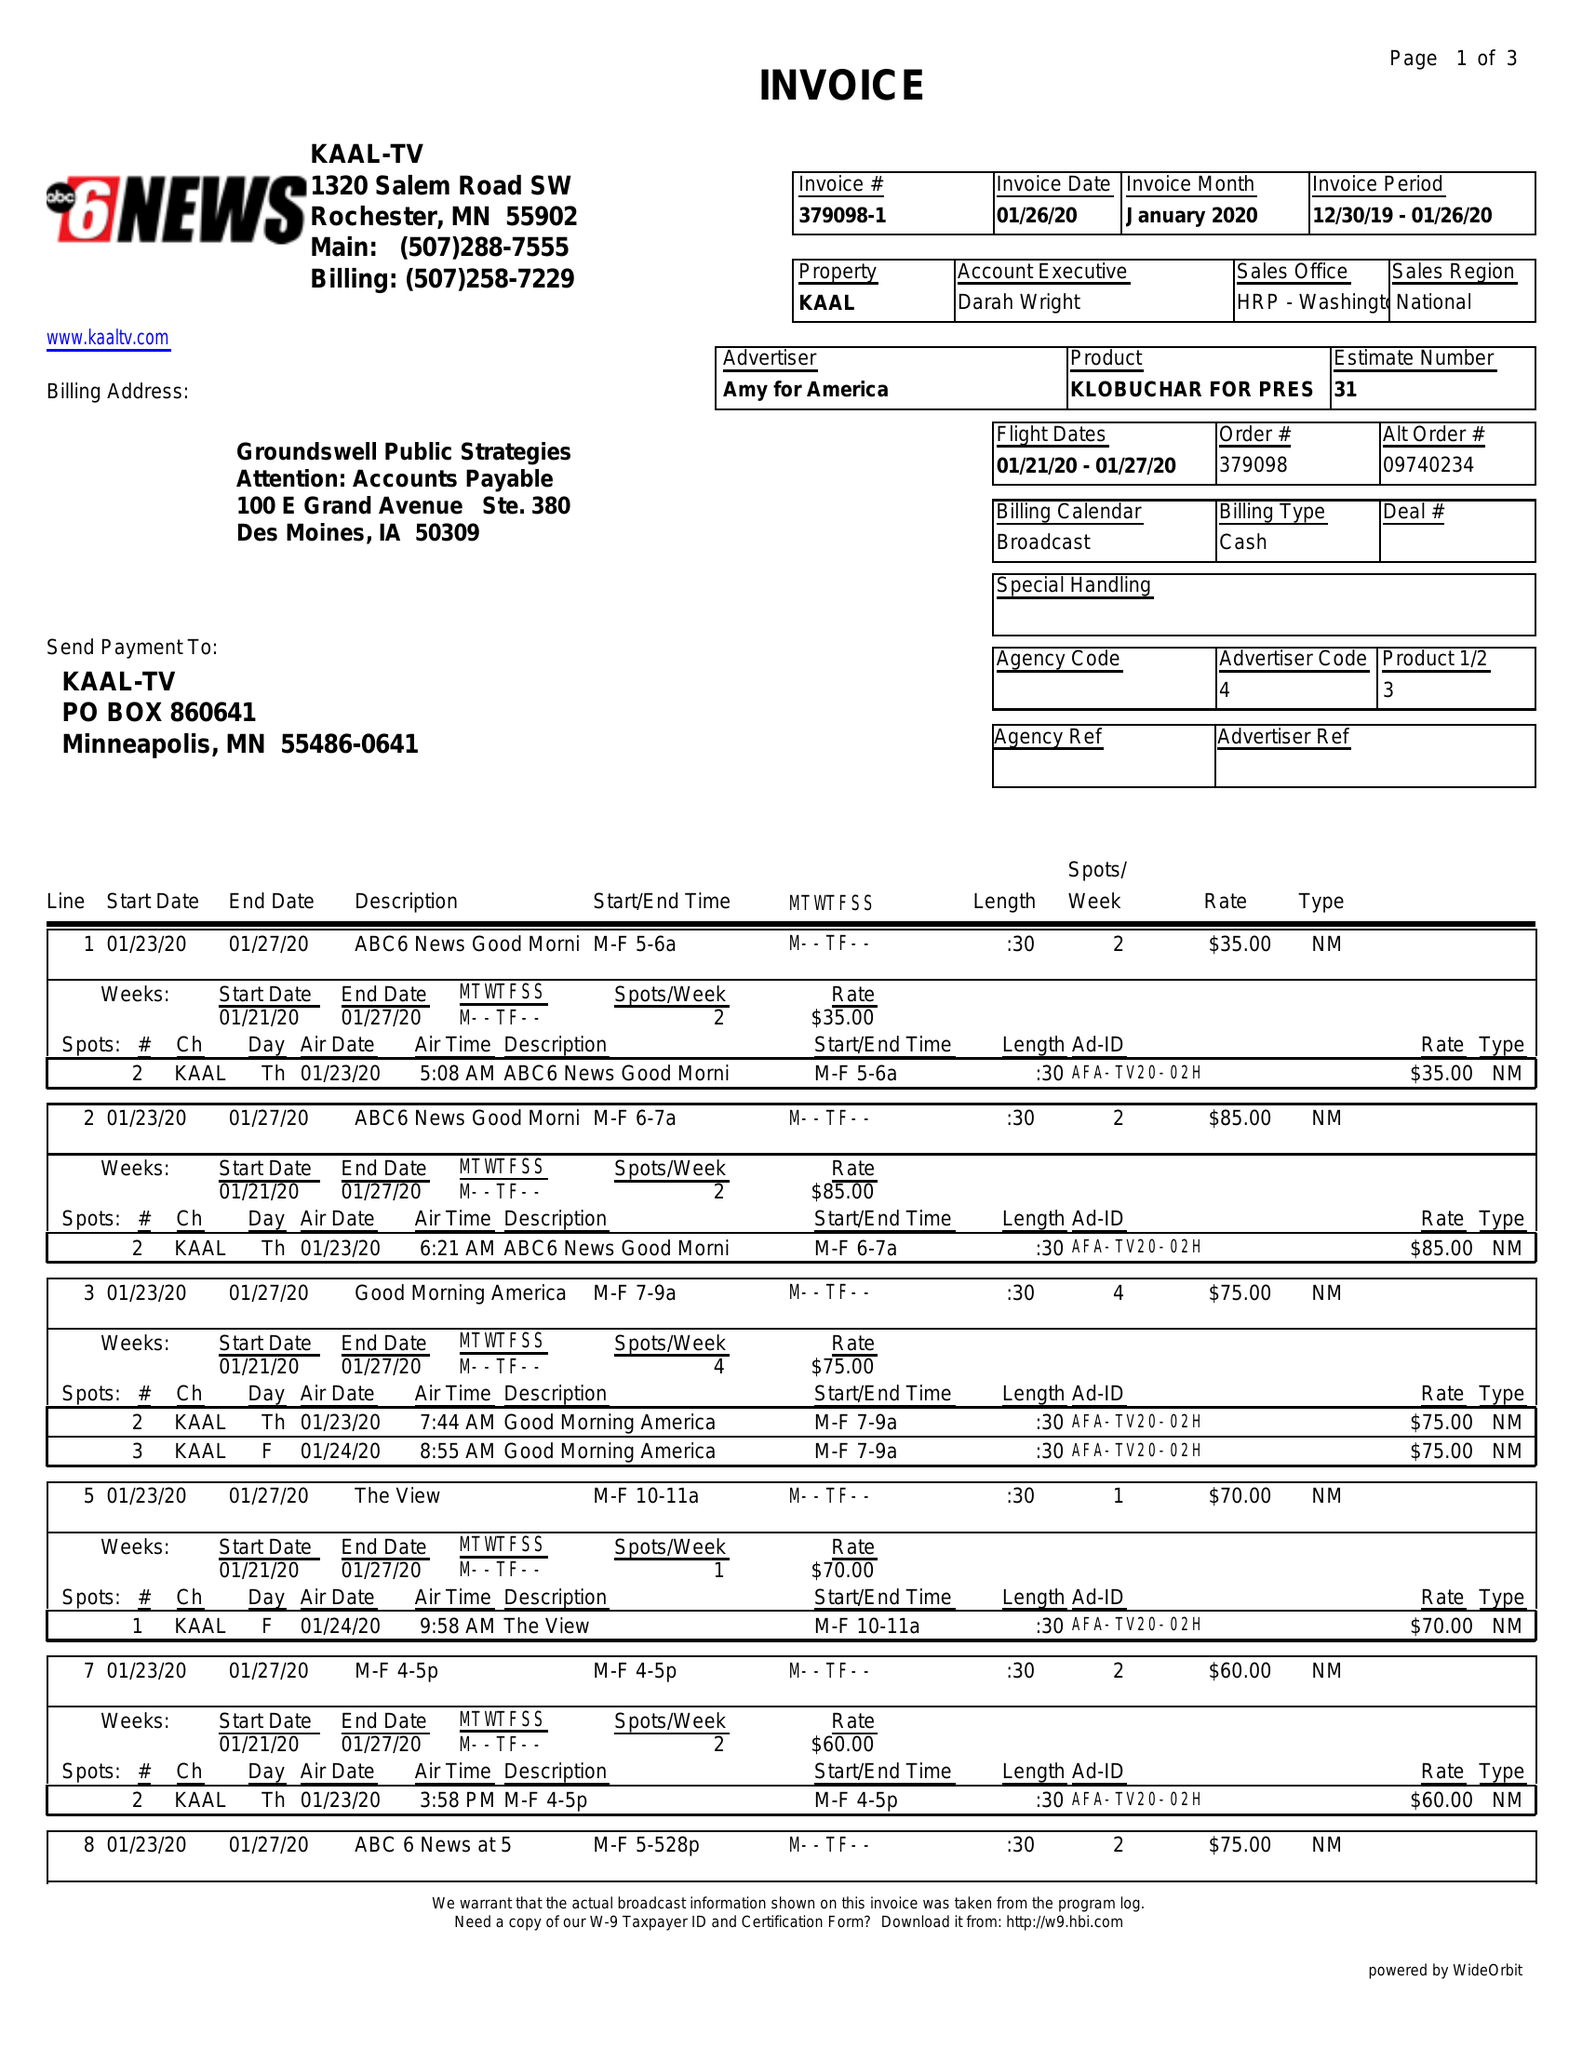What is the value for the flight_from?
Answer the question using a single word or phrase. 01/21/20 